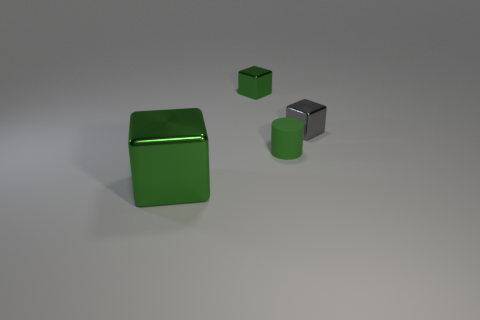Does the tiny green object in front of the gray cube have the same material as the tiny gray thing?
Give a very brief answer. No. What material is the tiny green thing that is behind the small green cylinder?
Provide a short and direct response. Metal. There is a green shiny object in front of the green metal cube behind the big green object; what size is it?
Your response must be concise. Large. Are there any gray things that have the same material as the big block?
Your response must be concise. Yes. There is a tiny matte object right of the green metallic object that is right of the block in front of the tiny green matte object; what shape is it?
Provide a short and direct response. Cylinder. Do the cube in front of the gray object and the metallic object that is on the right side of the tiny green matte cylinder have the same color?
Your response must be concise. No. Are there any other things that have the same size as the green matte thing?
Your response must be concise. Yes. Are there any tiny green matte cylinders left of the small green metal block?
Your answer should be compact. No. What number of small cyan objects are the same shape as the big green shiny thing?
Ensure brevity in your answer.  0. The metallic block that is on the right side of the tiny thing behind the tiny gray object that is to the right of the big thing is what color?
Offer a terse response. Gray. 